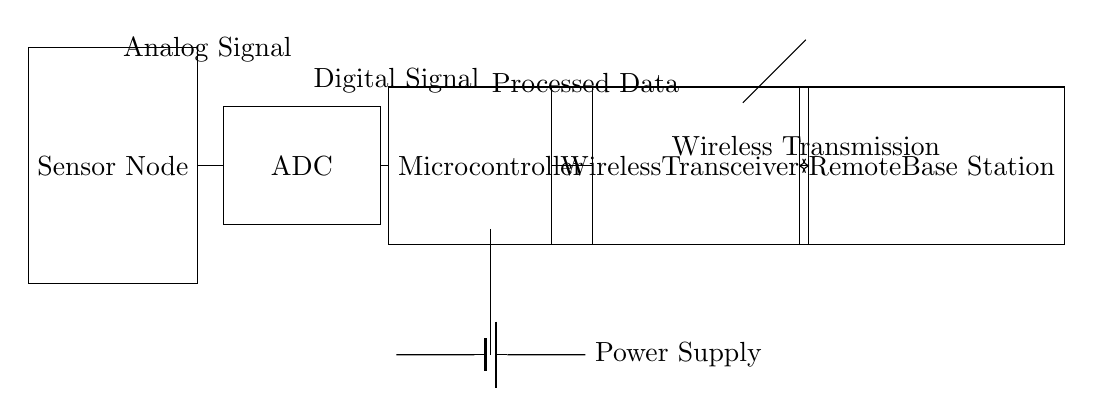What components are in this hybrid circuit? The circuit comprises a sensor node, an ADC, a microcontroller, and a wireless transceiver, along with a power supply and a remote base station.
Answer: sensor node, ADC, microcontroller, wireless transceiver, power supply, remote base station What type of signal does the sensor transmit? The sensor initially transmits an analog signal before it is converted by the ADC.
Answer: Analog signal What is the function of the ADC in this circuit? The ADC converts the analog signal from the sensor into a digital signal for processing by the microcontroller.
Answer: Convert analog to digital Which component handles data transmission to the remote base station? The wireless transceiver is responsible for sending processed data wirelessly to the remote base station.
Answer: Wireless transceiver How many main processing stages are present in this circuit? The circuit has three main processing stages: sensor node, ADC, and microcontroller. These stages work in succession to process the analog signal into a digital format and prepare it for transmission.
Answer: Three What is the purpose of the wireless connection in this circuit? The wireless connection allows for data transmission from the wireless transceiver to the remote base station without physical wiring, enabling remote monitoring and data acquisition.
Answer: Data transmission 